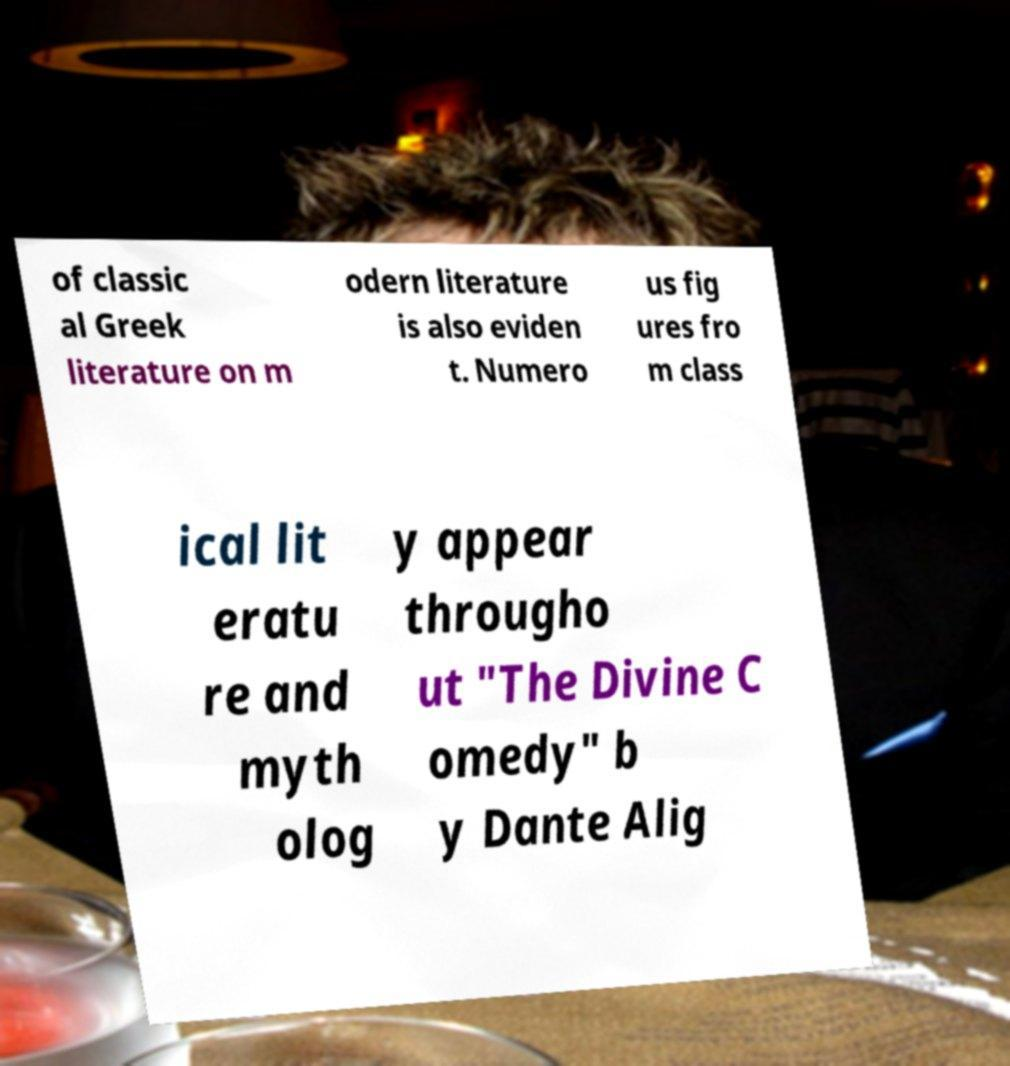Could you assist in decoding the text presented in this image and type it out clearly? of classic al Greek literature on m odern literature is also eviden t. Numero us fig ures fro m class ical lit eratu re and myth olog y appear througho ut "The Divine C omedy" b y Dante Alig 